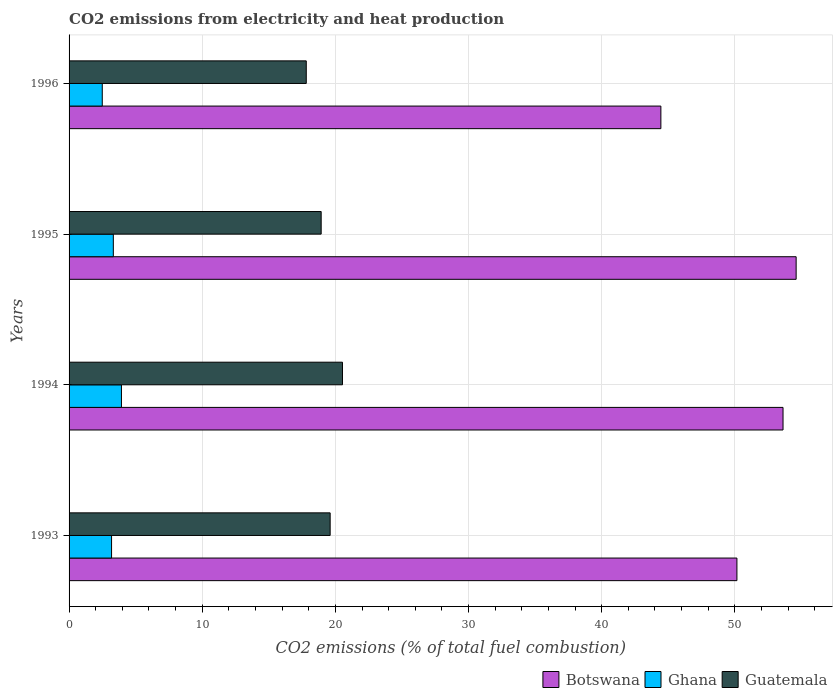How many different coloured bars are there?
Your answer should be very brief. 3. How many groups of bars are there?
Ensure brevity in your answer.  4. Are the number of bars on each tick of the Y-axis equal?
Provide a short and direct response. Yes. How many bars are there on the 2nd tick from the top?
Offer a very short reply. 3. What is the amount of CO2 emitted in Guatemala in 1994?
Give a very brief answer. 20.53. Across all years, what is the maximum amount of CO2 emitted in Ghana?
Ensure brevity in your answer.  3.93. Across all years, what is the minimum amount of CO2 emitted in Ghana?
Offer a terse response. 2.49. What is the total amount of CO2 emitted in Guatemala in the graph?
Provide a short and direct response. 76.89. What is the difference between the amount of CO2 emitted in Guatemala in 1994 and that in 1995?
Your response must be concise. 1.6. What is the difference between the amount of CO2 emitted in Botswana in 1993 and the amount of CO2 emitted in Guatemala in 1995?
Offer a very short reply. 31.22. What is the average amount of CO2 emitted in Botswana per year?
Ensure brevity in your answer.  50.71. In the year 1993, what is the difference between the amount of CO2 emitted in Ghana and amount of CO2 emitted in Botswana?
Ensure brevity in your answer.  -46.96. In how many years, is the amount of CO2 emitted in Botswana greater than 44 %?
Give a very brief answer. 4. What is the ratio of the amount of CO2 emitted in Ghana in 1994 to that in 1996?
Your answer should be very brief. 1.58. Is the amount of CO2 emitted in Ghana in 1994 less than that in 1996?
Provide a succinct answer. No. What is the difference between the highest and the second highest amount of CO2 emitted in Botswana?
Provide a succinct answer. 0.98. What is the difference between the highest and the lowest amount of CO2 emitted in Ghana?
Make the answer very short. 1.44. Is the sum of the amount of CO2 emitted in Guatemala in 1994 and 1996 greater than the maximum amount of CO2 emitted in Ghana across all years?
Provide a short and direct response. Yes. What does the 2nd bar from the top in 1996 represents?
Provide a short and direct response. Ghana. What does the 1st bar from the bottom in 1995 represents?
Provide a succinct answer. Botswana. Is it the case that in every year, the sum of the amount of CO2 emitted in Ghana and amount of CO2 emitted in Botswana is greater than the amount of CO2 emitted in Guatemala?
Your answer should be very brief. Yes. How many bars are there?
Your answer should be very brief. 12. Are all the bars in the graph horizontal?
Ensure brevity in your answer.  Yes. Are the values on the major ticks of X-axis written in scientific E-notation?
Provide a short and direct response. No. Where does the legend appear in the graph?
Offer a very short reply. Bottom right. How are the legend labels stacked?
Provide a succinct answer. Horizontal. What is the title of the graph?
Provide a short and direct response. CO2 emissions from electricity and heat production. What is the label or title of the X-axis?
Give a very brief answer. CO2 emissions (% of total fuel combustion). What is the CO2 emissions (% of total fuel combustion) in Botswana in 1993?
Keep it short and to the point. 50.16. What is the CO2 emissions (% of total fuel combustion) in Ghana in 1993?
Keep it short and to the point. 3.19. What is the CO2 emissions (% of total fuel combustion) of Guatemala in 1993?
Your answer should be compact. 19.61. What is the CO2 emissions (% of total fuel combustion) in Botswana in 1994?
Offer a very short reply. 53.62. What is the CO2 emissions (% of total fuel combustion) of Ghana in 1994?
Provide a short and direct response. 3.93. What is the CO2 emissions (% of total fuel combustion) of Guatemala in 1994?
Your response must be concise. 20.53. What is the CO2 emissions (% of total fuel combustion) in Botswana in 1995?
Your answer should be very brief. 54.6. What is the CO2 emissions (% of total fuel combustion) of Ghana in 1995?
Offer a terse response. 3.32. What is the CO2 emissions (% of total fuel combustion) of Guatemala in 1995?
Offer a very short reply. 18.93. What is the CO2 emissions (% of total fuel combustion) of Botswana in 1996?
Your answer should be compact. 44.44. What is the CO2 emissions (% of total fuel combustion) in Ghana in 1996?
Offer a very short reply. 2.49. What is the CO2 emissions (% of total fuel combustion) of Guatemala in 1996?
Your response must be concise. 17.81. Across all years, what is the maximum CO2 emissions (% of total fuel combustion) in Botswana?
Give a very brief answer. 54.6. Across all years, what is the maximum CO2 emissions (% of total fuel combustion) in Ghana?
Provide a succinct answer. 3.93. Across all years, what is the maximum CO2 emissions (% of total fuel combustion) in Guatemala?
Provide a short and direct response. 20.53. Across all years, what is the minimum CO2 emissions (% of total fuel combustion) of Botswana?
Offer a terse response. 44.44. Across all years, what is the minimum CO2 emissions (% of total fuel combustion) of Ghana?
Provide a short and direct response. 2.49. Across all years, what is the minimum CO2 emissions (% of total fuel combustion) in Guatemala?
Your answer should be compact. 17.81. What is the total CO2 emissions (% of total fuel combustion) of Botswana in the graph?
Keep it short and to the point. 202.82. What is the total CO2 emissions (% of total fuel combustion) in Ghana in the graph?
Your response must be concise. 12.94. What is the total CO2 emissions (% of total fuel combustion) in Guatemala in the graph?
Make the answer very short. 76.89. What is the difference between the CO2 emissions (% of total fuel combustion) of Botswana in 1993 and that in 1994?
Give a very brief answer. -3.46. What is the difference between the CO2 emissions (% of total fuel combustion) of Ghana in 1993 and that in 1994?
Provide a succinct answer. -0.74. What is the difference between the CO2 emissions (% of total fuel combustion) of Guatemala in 1993 and that in 1994?
Keep it short and to the point. -0.93. What is the difference between the CO2 emissions (% of total fuel combustion) in Botswana in 1993 and that in 1995?
Make the answer very short. -4.45. What is the difference between the CO2 emissions (% of total fuel combustion) of Ghana in 1993 and that in 1995?
Your answer should be compact. -0.13. What is the difference between the CO2 emissions (% of total fuel combustion) in Guatemala in 1993 and that in 1995?
Ensure brevity in your answer.  0.68. What is the difference between the CO2 emissions (% of total fuel combustion) in Botswana in 1993 and that in 1996?
Offer a terse response. 5.71. What is the difference between the CO2 emissions (% of total fuel combustion) in Ghana in 1993 and that in 1996?
Ensure brevity in your answer.  0.7. What is the difference between the CO2 emissions (% of total fuel combustion) of Guatemala in 1993 and that in 1996?
Provide a short and direct response. 1.79. What is the difference between the CO2 emissions (% of total fuel combustion) of Botswana in 1994 and that in 1995?
Keep it short and to the point. -0.98. What is the difference between the CO2 emissions (% of total fuel combustion) of Ghana in 1994 and that in 1995?
Your answer should be compact. 0.61. What is the difference between the CO2 emissions (% of total fuel combustion) in Guatemala in 1994 and that in 1995?
Your answer should be very brief. 1.6. What is the difference between the CO2 emissions (% of total fuel combustion) of Botswana in 1994 and that in 1996?
Provide a succinct answer. 9.17. What is the difference between the CO2 emissions (% of total fuel combustion) of Ghana in 1994 and that in 1996?
Provide a succinct answer. 1.44. What is the difference between the CO2 emissions (% of total fuel combustion) in Guatemala in 1994 and that in 1996?
Give a very brief answer. 2.72. What is the difference between the CO2 emissions (% of total fuel combustion) of Botswana in 1995 and that in 1996?
Offer a terse response. 10.16. What is the difference between the CO2 emissions (% of total fuel combustion) in Ghana in 1995 and that in 1996?
Offer a very short reply. 0.83. What is the difference between the CO2 emissions (% of total fuel combustion) of Guatemala in 1995 and that in 1996?
Your answer should be very brief. 1.12. What is the difference between the CO2 emissions (% of total fuel combustion) of Botswana in 1993 and the CO2 emissions (% of total fuel combustion) of Ghana in 1994?
Provide a succinct answer. 46.22. What is the difference between the CO2 emissions (% of total fuel combustion) in Botswana in 1993 and the CO2 emissions (% of total fuel combustion) in Guatemala in 1994?
Give a very brief answer. 29.62. What is the difference between the CO2 emissions (% of total fuel combustion) in Ghana in 1993 and the CO2 emissions (% of total fuel combustion) in Guatemala in 1994?
Make the answer very short. -17.34. What is the difference between the CO2 emissions (% of total fuel combustion) of Botswana in 1993 and the CO2 emissions (% of total fuel combustion) of Ghana in 1995?
Give a very brief answer. 46.83. What is the difference between the CO2 emissions (% of total fuel combustion) of Botswana in 1993 and the CO2 emissions (% of total fuel combustion) of Guatemala in 1995?
Your response must be concise. 31.22. What is the difference between the CO2 emissions (% of total fuel combustion) of Ghana in 1993 and the CO2 emissions (% of total fuel combustion) of Guatemala in 1995?
Keep it short and to the point. -15.74. What is the difference between the CO2 emissions (% of total fuel combustion) in Botswana in 1993 and the CO2 emissions (% of total fuel combustion) in Ghana in 1996?
Keep it short and to the point. 47.66. What is the difference between the CO2 emissions (% of total fuel combustion) in Botswana in 1993 and the CO2 emissions (% of total fuel combustion) in Guatemala in 1996?
Keep it short and to the point. 32.34. What is the difference between the CO2 emissions (% of total fuel combustion) in Ghana in 1993 and the CO2 emissions (% of total fuel combustion) in Guatemala in 1996?
Provide a succinct answer. -14.62. What is the difference between the CO2 emissions (% of total fuel combustion) of Botswana in 1994 and the CO2 emissions (% of total fuel combustion) of Ghana in 1995?
Make the answer very short. 50.3. What is the difference between the CO2 emissions (% of total fuel combustion) of Botswana in 1994 and the CO2 emissions (% of total fuel combustion) of Guatemala in 1995?
Your answer should be compact. 34.69. What is the difference between the CO2 emissions (% of total fuel combustion) in Ghana in 1994 and the CO2 emissions (% of total fuel combustion) in Guatemala in 1995?
Make the answer very short. -15. What is the difference between the CO2 emissions (% of total fuel combustion) of Botswana in 1994 and the CO2 emissions (% of total fuel combustion) of Ghana in 1996?
Provide a short and direct response. 51.13. What is the difference between the CO2 emissions (% of total fuel combustion) in Botswana in 1994 and the CO2 emissions (% of total fuel combustion) in Guatemala in 1996?
Your answer should be compact. 35.81. What is the difference between the CO2 emissions (% of total fuel combustion) of Ghana in 1994 and the CO2 emissions (% of total fuel combustion) of Guatemala in 1996?
Offer a very short reply. -13.88. What is the difference between the CO2 emissions (% of total fuel combustion) of Botswana in 1995 and the CO2 emissions (% of total fuel combustion) of Ghana in 1996?
Keep it short and to the point. 52.11. What is the difference between the CO2 emissions (% of total fuel combustion) in Botswana in 1995 and the CO2 emissions (% of total fuel combustion) in Guatemala in 1996?
Offer a very short reply. 36.79. What is the difference between the CO2 emissions (% of total fuel combustion) in Ghana in 1995 and the CO2 emissions (% of total fuel combustion) in Guatemala in 1996?
Make the answer very short. -14.49. What is the average CO2 emissions (% of total fuel combustion) in Botswana per year?
Offer a very short reply. 50.71. What is the average CO2 emissions (% of total fuel combustion) of Ghana per year?
Keep it short and to the point. 3.24. What is the average CO2 emissions (% of total fuel combustion) of Guatemala per year?
Ensure brevity in your answer.  19.22. In the year 1993, what is the difference between the CO2 emissions (% of total fuel combustion) of Botswana and CO2 emissions (% of total fuel combustion) of Ghana?
Offer a terse response. 46.96. In the year 1993, what is the difference between the CO2 emissions (% of total fuel combustion) in Botswana and CO2 emissions (% of total fuel combustion) in Guatemala?
Give a very brief answer. 30.55. In the year 1993, what is the difference between the CO2 emissions (% of total fuel combustion) of Ghana and CO2 emissions (% of total fuel combustion) of Guatemala?
Give a very brief answer. -16.42. In the year 1994, what is the difference between the CO2 emissions (% of total fuel combustion) in Botswana and CO2 emissions (% of total fuel combustion) in Ghana?
Offer a terse response. 49.68. In the year 1994, what is the difference between the CO2 emissions (% of total fuel combustion) in Botswana and CO2 emissions (% of total fuel combustion) in Guatemala?
Ensure brevity in your answer.  33.08. In the year 1994, what is the difference between the CO2 emissions (% of total fuel combustion) in Ghana and CO2 emissions (% of total fuel combustion) in Guatemala?
Offer a terse response. -16.6. In the year 1995, what is the difference between the CO2 emissions (% of total fuel combustion) of Botswana and CO2 emissions (% of total fuel combustion) of Ghana?
Provide a short and direct response. 51.28. In the year 1995, what is the difference between the CO2 emissions (% of total fuel combustion) in Botswana and CO2 emissions (% of total fuel combustion) in Guatemala?
Your response must be concise. 35.67. In the year 1995, what is the difference between the CO2 emissions (% of total fuel combustion) of Ghana and CO2 emissions (% of total fuel combustion) of Guatemala?
Ensure brevity in your answer.  -15.61. In the year 1996, what is the difference between the CO2 emissions (% of total fuel combustion) of Botswana and CO2 emissions (% of total fuel combustion) of Ghana?
Provide a succinct answer. 41.95. In the year 1996, what is the difference between the CO2 emissions (% of total fuel combustion) in Botswana and CO2 emissions (% of total fuel combustion) in Guatemala?
Your answer should be very brief. 26.63. In the year 1996, what is the difference between the CO2 emissions (% of total fuel combustion) of Ghana and CO2 emissions (% of total fuel combustion) of Guatemala?
Give a very brief answer. -15.32. What is the ratio of the CO2 emissions (% of total fuel combustion) in Botswana in 1993 to that in 1994?
Make the answer very short. 0.94. What is the ratio of the CO2 emissions (% of total fuel combustion) of Ghana in 1993 to that in 1994?
Your response must be concise. 0.81. What is the ratio of the CO2 emissions (% of total fuel combustion) in Guatemala in 1993 to that in 1994?
Provide a succinct answer. 0.95. What is the ratio of the CO2 emissions (% of total fuel combustion) in Botswana in 1993 to that in 1995?
Your answer should be compact. 0.92. What is the ratio of the CO2 emissions (% of total fuel combustion) of Ghana in 1993 to that in 1995?
Ensure brevity in your answer.  0.96. What is the ratio of the CO2 emissions (% of total fuel combustion) of Guatemala in 1993 to that in 1995?
Provide a short and direct response. 1.04. What is the ratio of the CO2 emissions (% of total fuel combustion) of Botswana in 1993 to that in 1996?
Offer a very short reply. 1.13. What is the ratio of the CO2 emissions (% of total fuel combustion) of Ghana in 1993 to that in 1996?
Provide a succinct answer. 1.28. What is the ratio of the CO2 emissions (% of total fuel combustion) in Guatemala in 1993 to that in 1996?
Your response must be concise. 1.1. What is the ratio of the CO2 emissions (% of total fuel combustion) of Botswana in 1994 to that in 1995?
Provide a succinct answer. 0.98. What is the ratio of the CO2 emissions (% of total fuel combustion) in Ghana in 1994 to that in 1995?
Ensure brevity in your answer.  1.18. What is the ratio of the CO2 emissions (% of total fuel combustion) of Guatemala in 1994 to that in 1995?
Offer a terse response. 1.08. What is the ratio of the CO2 emissions (% of total fuel combustion) in Botswana in 1994 to that in 1996?
Your answer should be compact. 1.21. What is the ratio of the CO2 emissions (% of total fuel combustion) of Ghana in 1994 to that in 1996?
Make the answer very short. 1.58. What is the ratio of the CO2 emissions (% of total fuel combustion) in Guatemala in 1994 to that in 1996?
Keep it short and to the point. 1.15. What is the ratio of the CO2 emissions (% of total fuel combustion) of Botswana in 1995 to that in 1996?
Offer a terse response. 1.23. What is the ratio of the CO2 emissions (% of total fuel combustion) in Ghana in 1995 to that in 1996?
Make the answer very short. 1.33. What is the ratio of the CO2 emissions (% of total fuel combustion) in Guatemala in 1995 to that in 1996?
Your answer should be compact. 1.06. What is the difference between the highest and the second highest CO2 emissions (% of total fuel combustion) of Botswana?
Make the answer very short. 0.98. What is the difference between the highest and the second highest CO2 emissions (% of total fuel combustion) in Ghana?
Offer a very short reply. 0.61. What is the difference between the highest and the second highest CO2 emissions (% of total fuel combustion) of Guatemala?
Make the answer very short. 0.93. What is the difference between the highest and the lowest CO2 emissions (% of total fuel combustion) in Botswana?
Make the answer very short. 10.16. What is the difference between the highest and the lowest CO2 emissions (% of total fuel combustion) in Ghana?
Your response must be concise. 1.44. What is the difference between the highest and the lowest CO2 emissions (% of total fuel combustion) of Guatemala?
Your response must be concise. 2.72. 